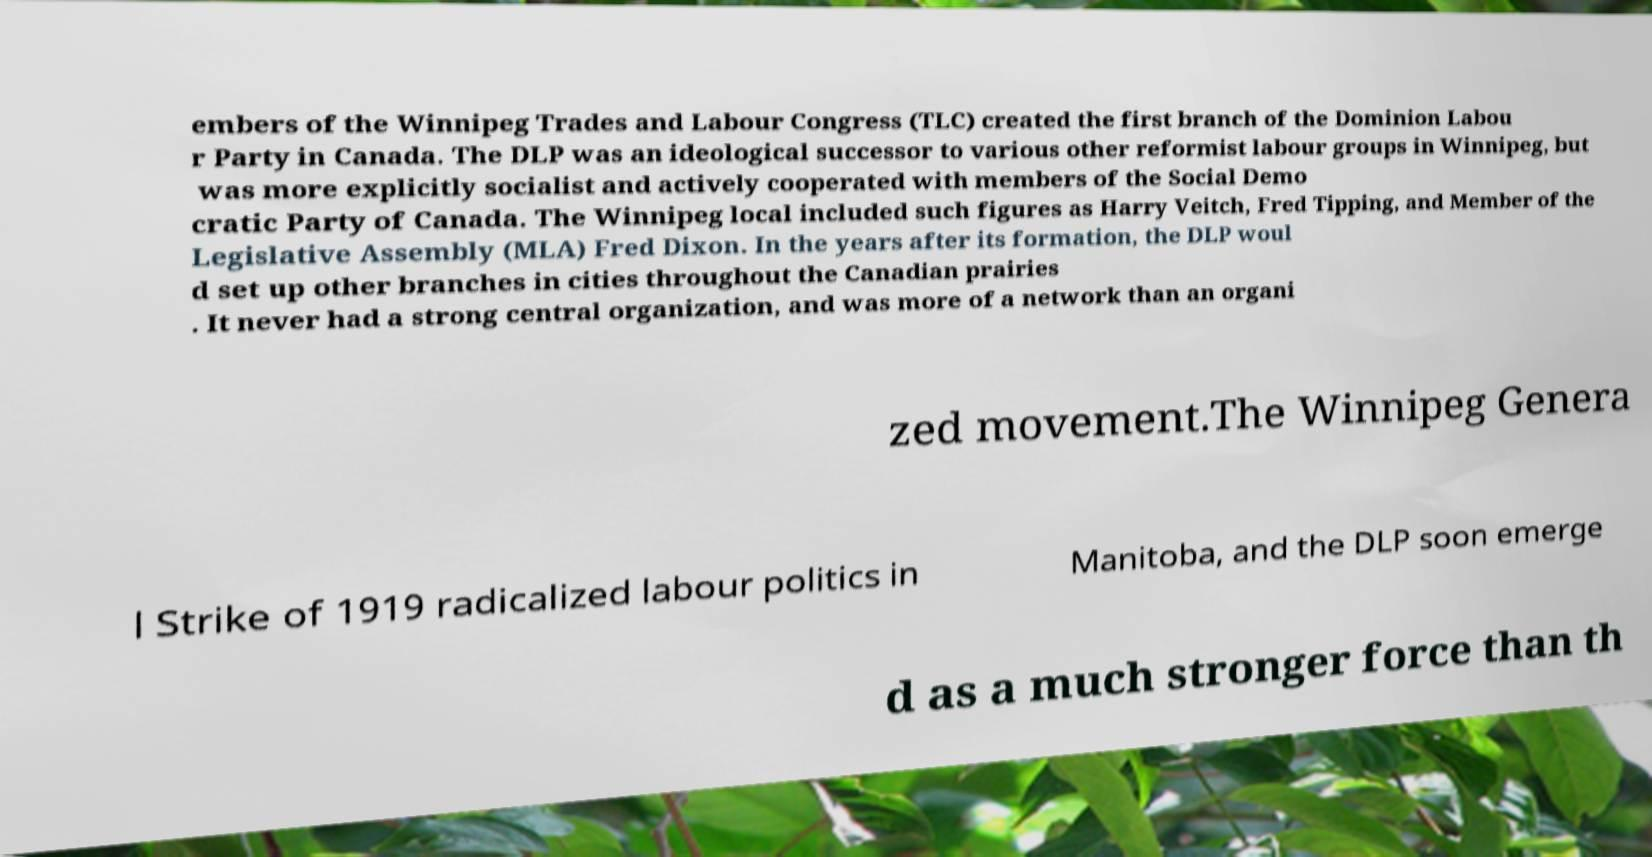Can you accurately transcribe the text from the provided image for me? embers of the Winnipeg Trades and Labour Congress (TLC) created the first branch of the Dominion Labou r Party in Canada. The DLP was an ideological successor to various other reformist labour groups in Winnipeg, but was more explicitly socialist and actively cooperated with members of the Social Demo cratic Party of Canada. The Winnipeg local included such figures as Harry Veitch, Fred Tipping, and Member of the Legislative Assembly (MLA) Fred Dixon. In the years after its formation, the DLP woul d set up other branches in cities throughout the Canadian prairies . It never had a strong central organization, and was more of a network than an organi zed movement.The Winnipeg Genera l Strike of 1919 radicalized labour politics in Manitoba, and the DLP soon emerge d as a much stronger force than th 